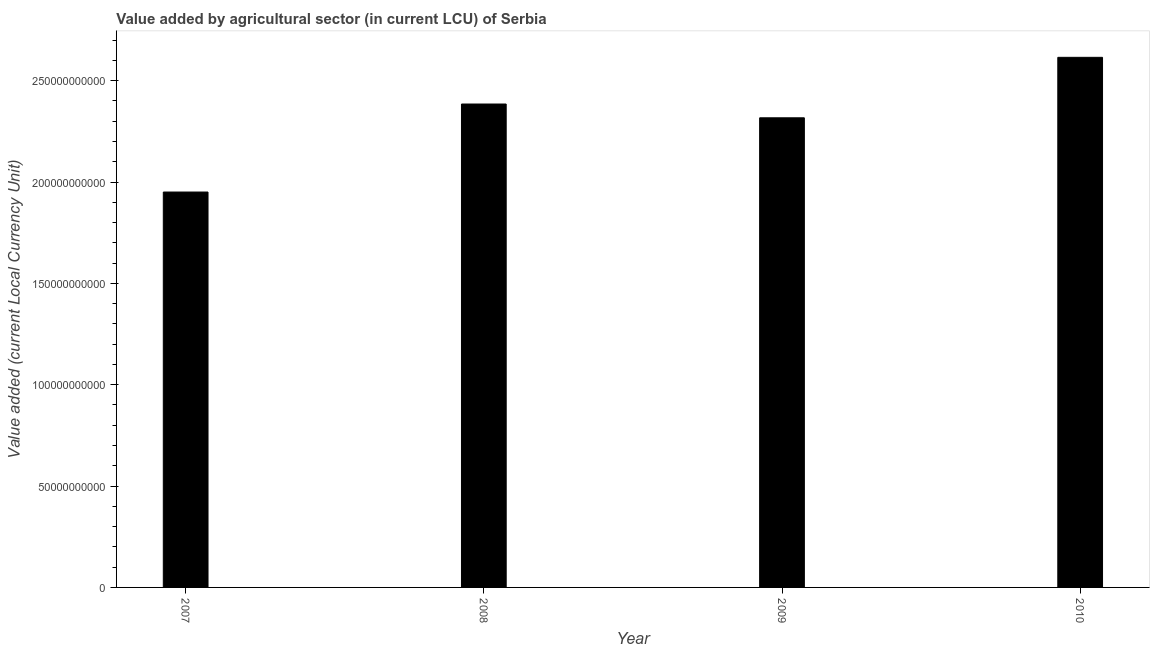Does the graph contain any zero values?
Ensure brevity in your answer.  No. What is the title of the graph?
Ensure brevity in your answer.  Value added by agricultural sector (in current LCU) of Serbia. What is the label or title of the Y-axis?
Keep it short and to the point. Value added (current Local Currency Unit). What is the value added by agriculture sector in 2009?
Your answer should be very brief. 2.32e+11. Across all years, what is the maximum value added by agriculture sector?
Provide a succinct answer. 2.62e+11. Across all years, what is the minimum value added by agriculture sector?
Ensure brevity in your answer.  1.95e+11. In which year was the value added by agriculture sector minimum?
Your answer should be compact. 2007. What is the sum of the value added by agriculture sector?
Ensure brevity in your answer.  9.27e+11. What is the difference between the value added by agriculture sector in 2007 and 2008?
Offer a terse response. -4.34e+1. What is the average value added by agriculture sector per year?
Provide a succinct answer. 2.32e+11. What is the median value added by agriculture sector?
Keep it short and to the point. 2.35e+11. In how many years, is the value added by agriculture sector greater than 80000000000 LCU?
Your answer should be compact. 4. Do a majority of the years between 2008 and 2010 (inclusive) have value added by agriculture sector greater than 220000000000 LCU?
Offer a terse response. Yes. What is the ratio of the value added by agriculture sector in 2007 to that in 2008?
Keep it short and to the point. 0.82. Is the difference between the value added by agriculture sector in 2009 and 2010 greater than the difference between any two years?
Keep it short and to the point. No. What is the difference between the highest and the second highest value added by agriculture sector?
Keep it short and to the point. 2.30e+1. What is the difference between the highest and the lowest value added by agriculture sector?
Your answer should be compact. 6.65e+1. In how many years, is the value added by agriculture sector greater than the average value added by agriculture sector taken over all years?
Your answer should be very brief. 2. How many bars are there?
Provide a succinct answer. 4. What is the Value added (current Local Currency Unit) of 2007?
Make the answer very short. 1.95e+11. What is the Value added (current Local Currency Unit) in 2008?
Offer a very short reply. 2.38e+11. What is the Value added (current Local Currency Unit) in 2009?
Offer a very short reply. 2.32e+11. What is the Value added (current Local Currency Unit) in 2010?
Your response must be concise. 2.62e+11. What is the difference between the Value added (current Local Currency Unit) in 2007 and 2008?
Give a very brief answer. -4.34e+1. What is the difference between the Value added (current Local Currency Unit) in 2007 and 2009?
Offer a very short reply. -3.66e+1. What is the difference between the Value added (current Local Currency Unit) in 2007 and 2010?
Offer a very short reply. -6.65e+1. What is the difference between the Value added (current Local Currency Unit) in 2008 and 2009?
Give a very brief answer. 6.80e+09. What is the difference between the Value added (current Local Currency Unit) in 2008 and 2010?
Give a very brief answer. -2.30e+1. What is the difference between the Value added (current Local Currency Unit) in 2009 and 2010?
Give a very brief answer. -2.98e+1. What is the ratio of the Value added (current Local Currency Unit) in 2007 to that in 2008?
Offer a terse response. 0.82. What is the ratio of the Value added (current Local Currency Unit) in 2007 to that in 2009?
Your response must be concise. 0.84. What is the ratio of the Value added (current Local Currency Unit) in 2007 to that in 2010?
Offer a terse response. 0.75. What is the ratio of the Value added (current Local Currency Unit) in 2008 to that in 2010?
Your response must be concise. 0.91. What is the ratio of the Value added (current Local Currency Unit) in 2009 to that in 2010?
Provide a short and direct response. 0.89. 